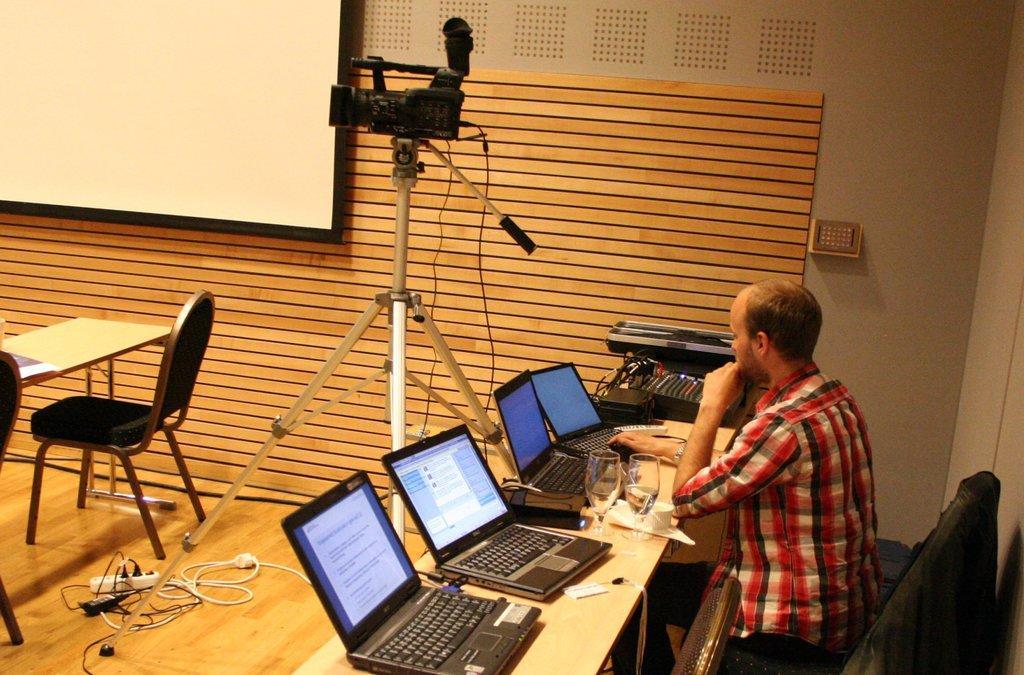In one or two sentences, can you explain what this image depicts? The image is inside the room. In the image there is a man sitting on chair in front of a table, on table we can see glass,laptop,wireless,printer. In middle there is a camera, on right side we can see a table and a chair, white color board on wall at bottom there is a switchboard and some wires. 